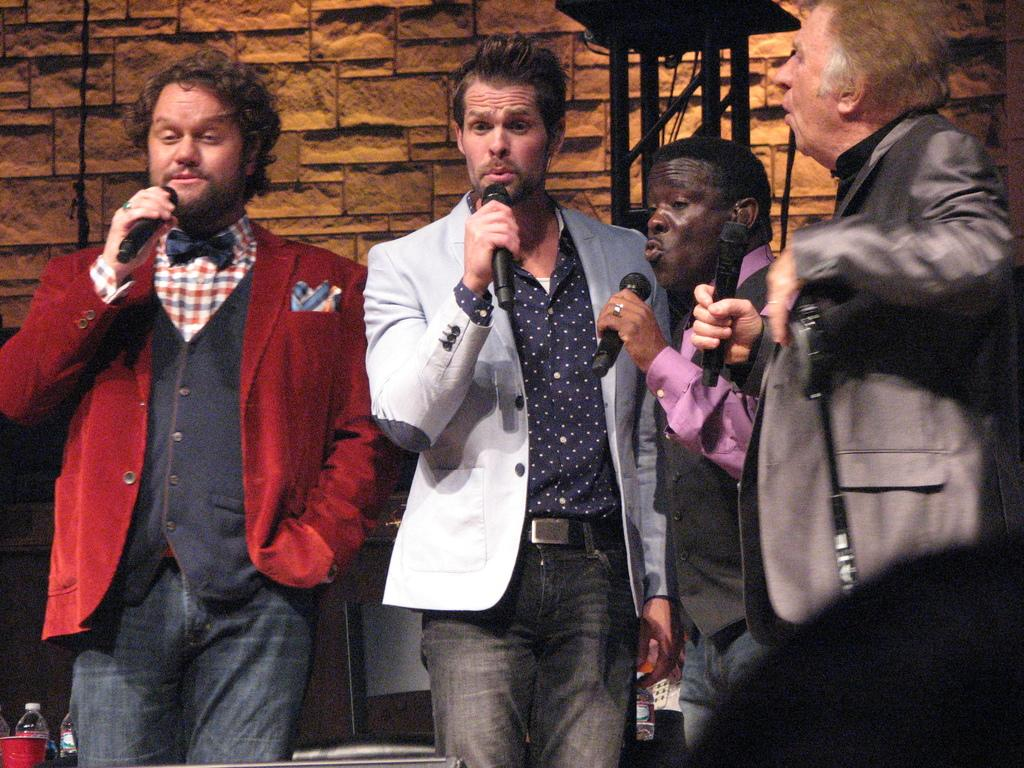How many people are in the image? There are four men in the image. What are the men doing in the image? The men are standing and singing a song. What are the men holding in the image? The men are holding microphones. What can be seen in the background of the image? There is a wall visible in the background of the image. Can you tell me the rate at which the waves are crashing on the seashore in the image? There is no seashore or waves present in the image; it features four men singing with microphones and a wall in the background. 